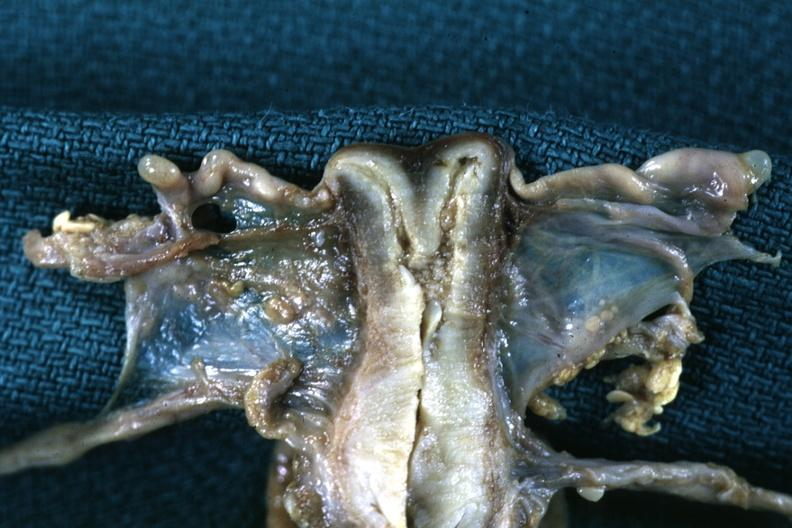s uterus present?
Answer the question using a single word or phrase. Yes 